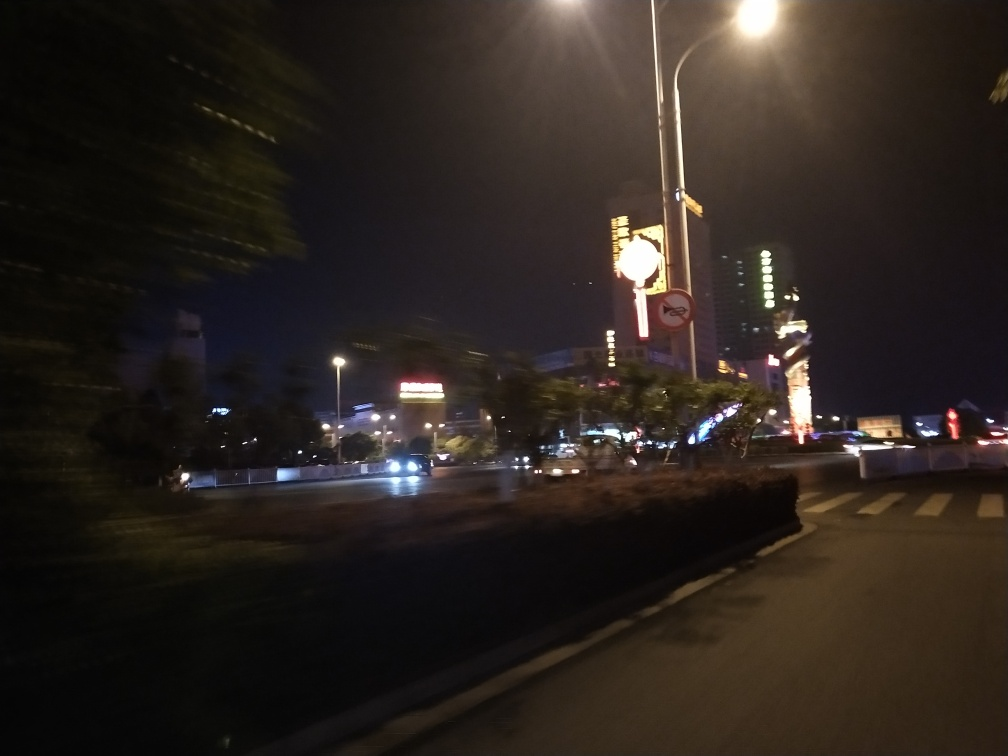What visual elements suggest this photo was taken in a hurry or while in motion? The most evident visual element suggesting that the photo was taken in haste or while in motion is the blur that extends across the entire image. It is most pronounced in the streaking lights from the street lamps and the headlights of the cars, which typically occurs when the camera is moving during the exposure. Also, the angle of the scene is slightly tilted, which can occur when a photo is snapped quickly without taking the time to level the camera. 